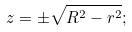<formula> <loc_0><loc_0><loc_500><loc_500>z = \pm \sqrt { R ^ { 2 } - r ^ { 2 } } ;</formula> 